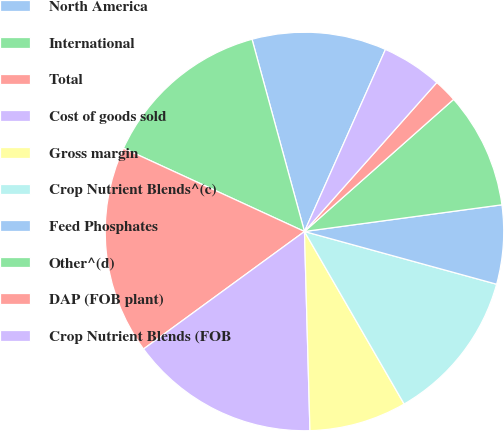<chart> <loc_0><loc_0><loc_500><loc_500><pie_chart><fcel>North America<fcel>International<fcel>Total<fcel>Cost of goods sold<fcel>Gross margin<fcel>Crop Nutrient Blends^(c)<fcel>Feed Phosphates<fcel>Other^(d)<fcel>DAP (FOB plant)<fcel>Crop Nutrient Blends (FOB<nl><fcel>10.9%<fcel>13.9%<fcel>16.9%<fcel>15.4%<fcel>7.9%<fcel>12.4%<fcel>6.4%<fcel>9.4%<fcel>1.9%<fcel>4.9%<nl></chart> 